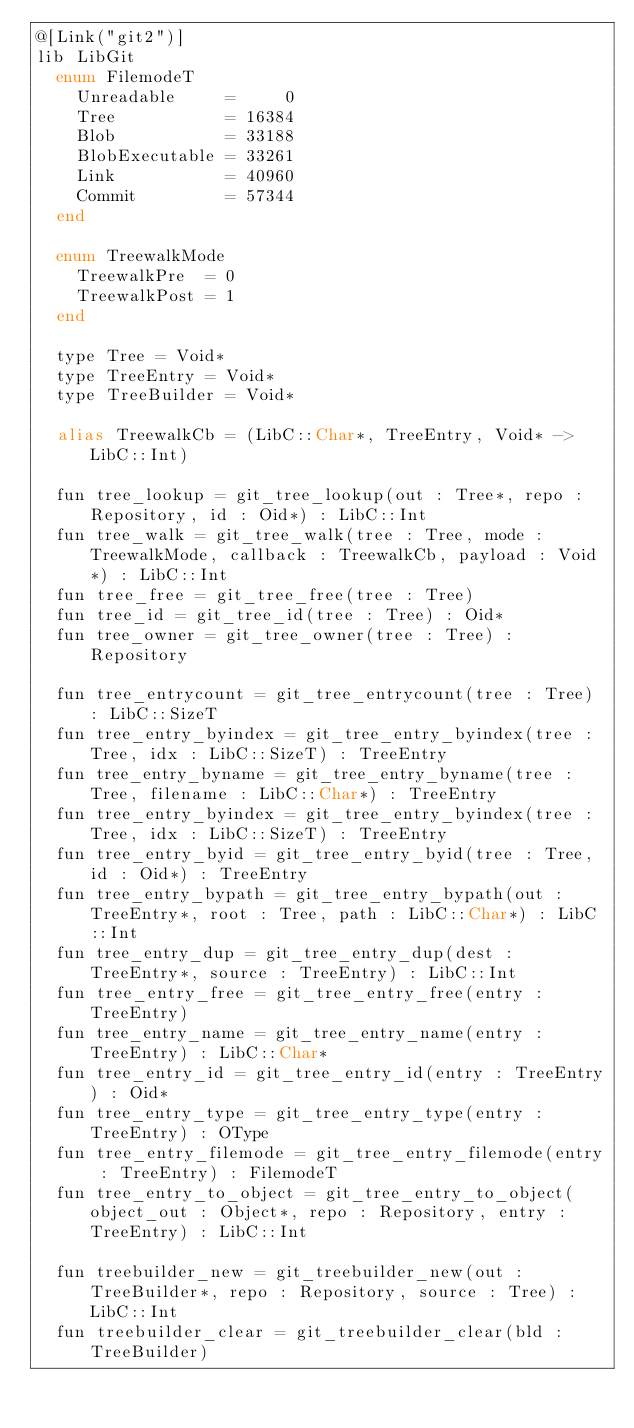Convert code to text. <code><loc_0><loc_0><loc_500><loc_500><_Crystal_>@[Link("git2")]
lib LibGit
  enum FilemodeT
    Unreadable     =     0
    Tree           = 16384
    Blob           = 33188
    BlobExecutable = 33261
    Link           = 40960
    Commit         = 57344
  end

  enum TreewalkMode
    TreewalkPre  = 0
    TreewalkPost = 1
  end

  type Tree = Void*
  type TreeEntry = Void*
  type TreeBuilder = Void*

  alias TreewalkCb = (LibC::Char*, TreeEntry, Void* -> LibC::Int)

  fun tree_lookup = git_tree_lookup(out : Tree*, repo : Repository, id : Oid*) : LibC::Int
  fun tree_walk = git_tree_walk(tree : Tree, mode : TreewalkMode, callback : TreewalkCb, payload : Void*) : LibC::Int
  fun tree_free = git_tree_free(tree : Tree)
  fun tree_id = git_tree_id(tree : Tree) : Oid*
  fun tree_owner = git_tree_owner(tree : Tree) : Repository

  fun tree_entrycount = git_tree_entrycount(tree : Tree) : LibC::SizeT
  fun tree_entry_byindex = git_tree_entry_byindex(tree : Tree, idx : LibC::SizeT) : TreeEntry
  fun tree_entry_byname = git_tree_entry_byname(tree : Tree, filename : LibC::Char*) : TreeEntry
  fun tree_entry_byindex = git_tree_entry_byindex(tree : Tree, idx : LibC::SizeT) : TreeEntry
  fun tree_entry_byid = git_tree_entry_byid(tree : Tree, id : Oid*) : TreeEntry
  fun tree_entry_bypath = git_tree_entry_bypath(out : TreeEntry*, root : Tree, path : LibC::Char*) : LibC::Int
  fun tree_entry_dup = git_tree_entry_dup(dest : TreeEntry*, source : TreeEntry) : LibC::Int
  fun tree_entry_free = git_tree_entry_free(entry : TreeEntry)
  fun tree_entry_name = git_tree_entry_name(entry : TreeEntry) : LibC::Char*
  fun tree_entry_id = git_tree_entry_id(entry : TreeEntry) : Oid*
  fun tree_entry_type = git_tree_entry_type(entry : TreeEntry) : OType
  fun tree_entry_filemode = git_tree_entry_filemode(entry : TreeEntry) : FilemodeT
  fun tree_entry_to_object = git_tree_entry_to_object(object_out : Object*, repo : Repository, entry : TreeEntry) : LibC::Int

  fun treebuilder_new = git_treebuilder_new(out : TreeBuilder*, repo : Repository, source : Tree) : LibC::Int
  fun treebuilder_clear = git_treebuilder_clear(bld : TreeBuilder)</code> 